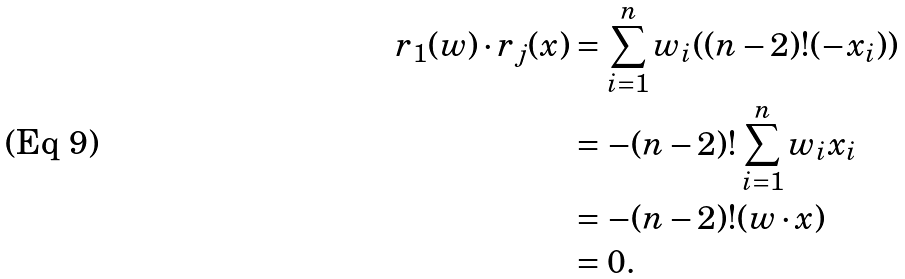<formula> <loc_0><loc_0><loc_500><loc_500>r _ { 1 } ( w ) \cdot r _ { j } ( x ) & = \sum _ { i = 1 } ^ { n } w _ { i } ( ( n - 2 ) ! ( - x _ { i } ) ) \\ & = - ( n - 2 ) ! \sum _ { i = 1 } ^ { n } w _ { i } x _ { i } \\ & = - ( n - 2 ) ! ( w \cdot x ) \\ & = 0 .</formula> 